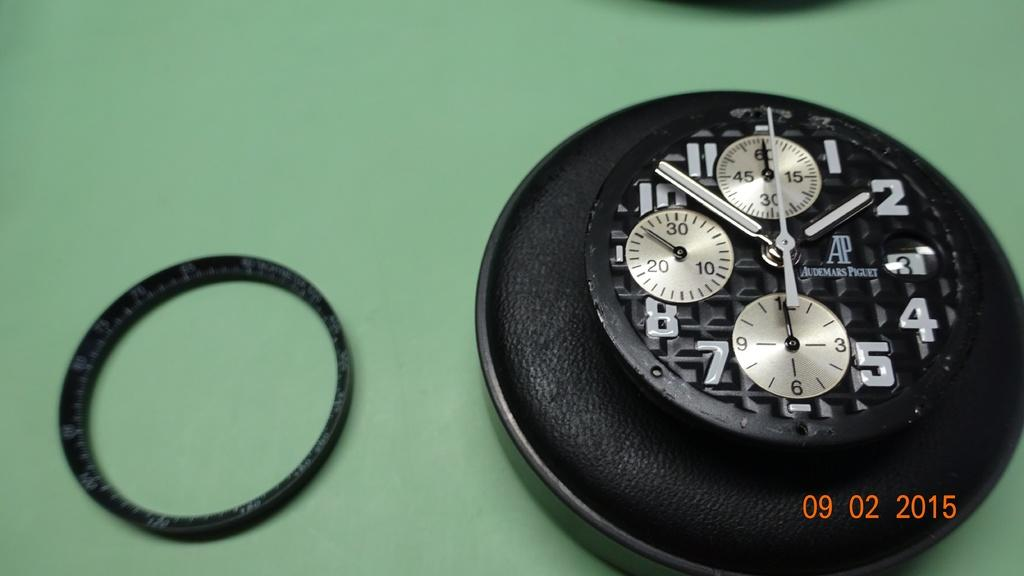<image>
Present a compact description of the photo's key features. An Audemars Piguet time piece shows the time of 1:52. 